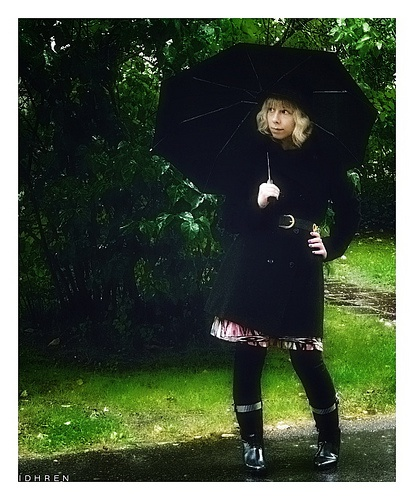Describe the objects in this image and their specific colors. I can see people in white, black, gray, and darkgreen tones and umbrella in white, black, teal, and darkgreen tones in this image. 